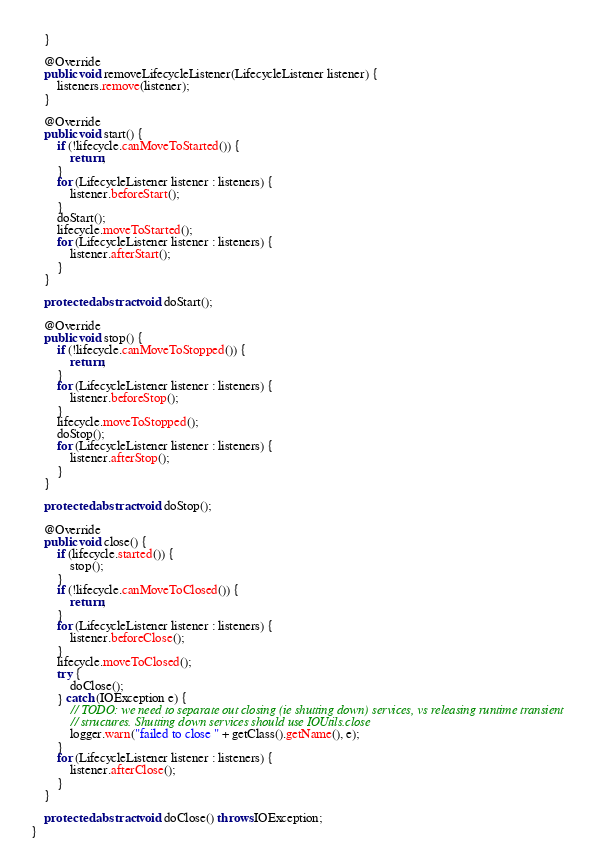<code> <loc_0><loc_0><loc_500><loc_500><_Java_>    }

    @Override
    public void removeLifecycleListener(LifecycleListener listener) {
        listeners.remove(listener);
    }

    @Override
    public void start() {
        if (!lifecycle.canMoveToStarted()) {
            return;
        }
        for (LifecycleListener listener : listeners) {
            listener.beforeStart();
        }
        doStart();
        lifecycle.moveToStarted();
        for (LifecycleListener listener : listeners) {
            listener.afterStart();
        }
    }

    protected abstract void doStart();

    @Override
    public void stop() {
        if (!lifecycle.canMoveToStopped()) {
            return;
        }
        for (LifecycleListener listener : listeners) {
            listener.beforeStop();
        }
        lifecycle.moveToStopped();
        doStop();
        for (LifecycleListener listener : listeners) {
            listener.afterStop();
        }
    }

    protected abstract void doStop();

    @Override
    public void close() {
        if (lifecycle.started()) {
            stop();
        }
        if (!lifecycle.canMoveToClosed()) {
            return;
        }
        for (LifecycleListener listener : listeners) {
            listener.beforeClose();
        }
        lifecycle.moveToClosed();
        try {
            doClose();
        } catch (IOException e) {
            // TODO: we need to separate out closing (ie shutting down) services, vs releasing runtime transient
            // structures. Shutting down services should use IOUtils.close
            logger.warn("failed to close " + getClass().getName(), e);
        }
        for (LifecycleListener listener : listeners) {
            listener.afterClose();
        }
    }

    protected abstract void doClose() throws IOException;
}
</code> 